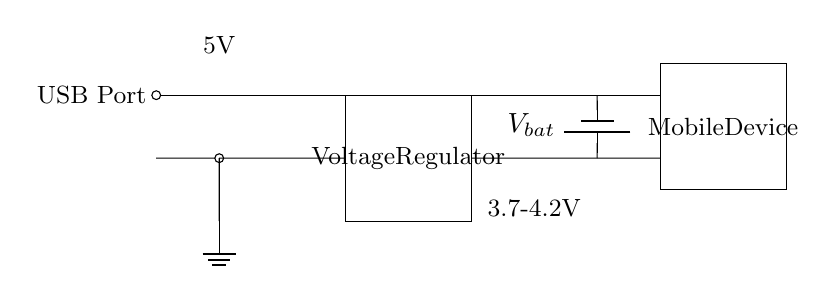What is the purpose of the voltage regulator? The voltage regulator's purpose is to maintain a constant output voltage of 5 volts despite variations in input voltage or load conditions. This ensures that the mobile device receives a stable and adequate voltage for charging.
Answer: voltage regulator What is the output voltage of the circuit? The output voltage, indicated in the diagram, is 5V, which is delivered to the mobile device from the voltage regulator.
Answer: 5V What is the voltage range of the battery? The voltage range of the battery is labeled as 3.7-4.2V, showing the typical voltage level at which lithium-ion batteries operate.
Answer: 3.7-4.2V How many main components are in the circuit? The main components visible in the circuit are four: the USB port, voltage regulator, battery, and mobile device. Each plays a crucial role in the charging process.
Answer: four What is the function of the USB port in this circuit? The USB port serves as the input connection point for the charging current to be supplied to the voltage regulator, making it the initial point for power delivery.
Answer: input connection Why is the ground connection important in this circuit? The ground connection is vital as it establishes a reference point for the circuit's voltage levels and provides a return path for the electric current, ensuring proper operation and safety of the circuit.
Answer: reference point 